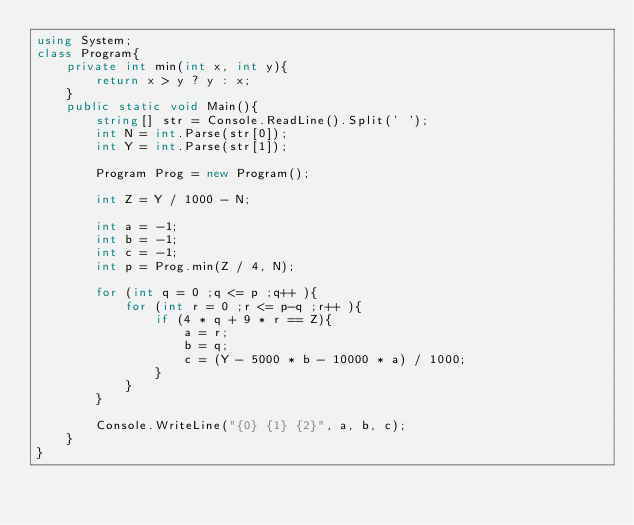<code> <loc_0><loc_0><loc_500><loc_500><_C#_>using System;
class Program{
	private int min(int x, int y){
		return x > y ? y : x;
	}
	public static void Main(){
		string[] str = Console.ReadLine().Split(' ');
		int N = int.Parse(str[0]);
		int Y = int.Parse(str[1]);
		
		Program Prog = new Program();
		
		int Z = Y / 1000 - N;
		
		int a = -1;
		int b = -1;
		int c = -1;
		int p = Prog.min(Z / 4, N);
		
		for (int q = 0 ;q <= p ;q++ ){
			for (int r = 0 ;r <= p-q ;r++ ){
				if (4 * q + 9 * r == Z){
					a = r;
					b = q;
					c = (Y - 5000 * b - 10000 * a) / 1000;
				}
			}
		}
		
		Console.WriteLine("{0} {1} {2}", a, b, c);
	}
}</code> 